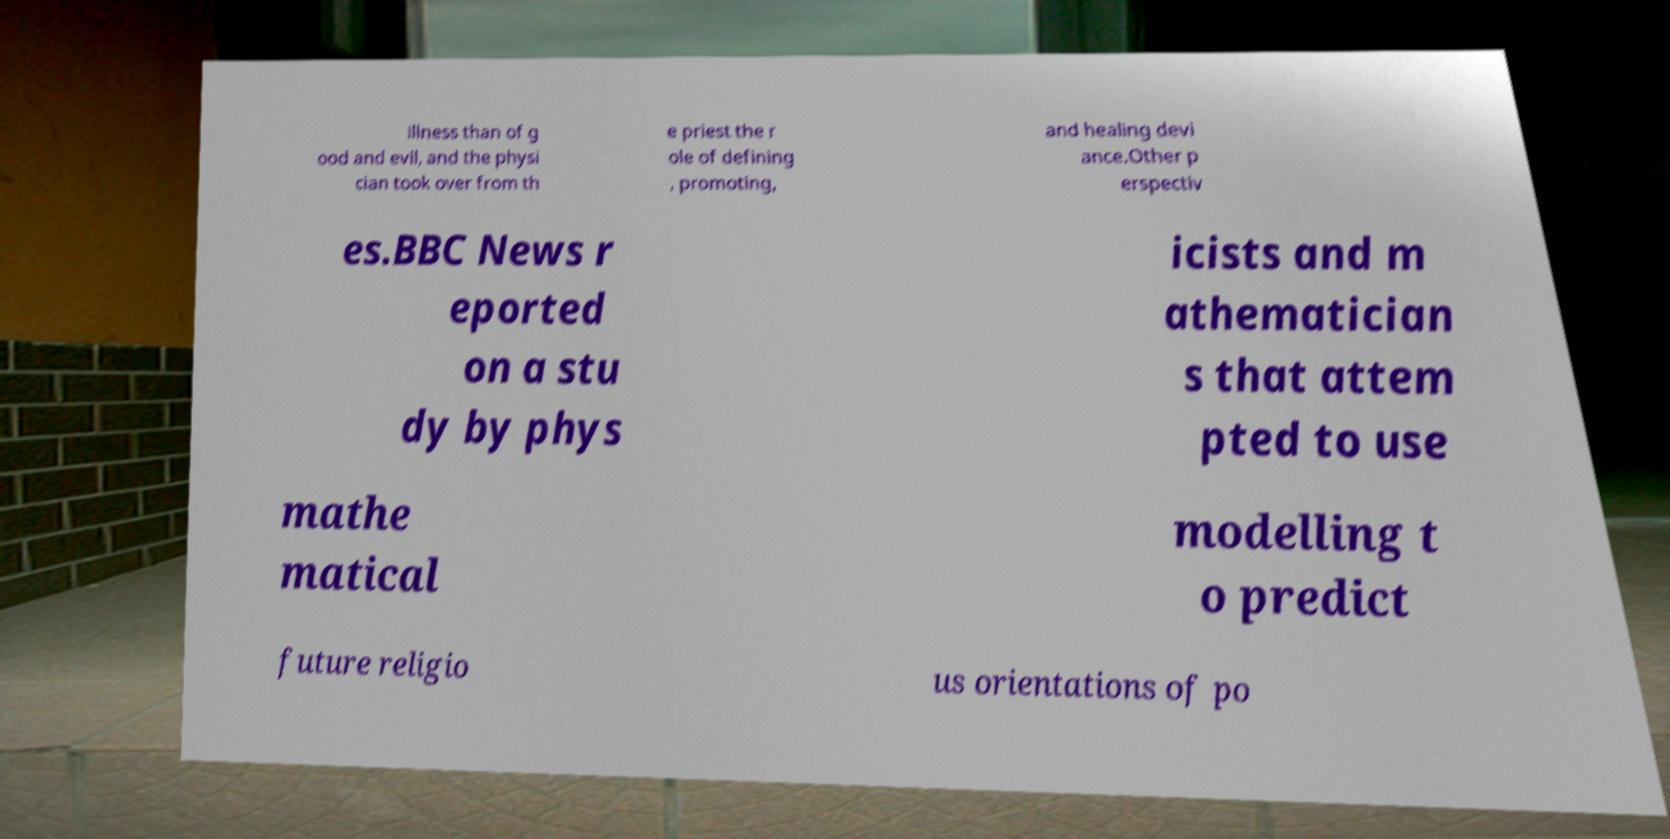Could you assist in decoding the text presented in this image and type it out clearly? illness than of g ood and evil, and the physi cian took over from th e priest the r ole of defining , promoting, and healing devi ance.Other p erspectiv es.BBC News r eported on a stu dy by phys icists and m athematician s that attem pted to use mathe matical modelling t o predict future religio us orientations of po 